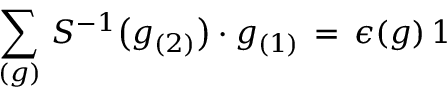Convert formula to latex. <formula><loc_0><loc_0><loc_500><loc_500>\sum _ { ( g ) } \, S ^ { - 1 } \left ( g _ { ( 2 ) } \right ) \cdot g _ { ( 1 ) } \, = \, \epsilon ( g ) \, 1</formula> 